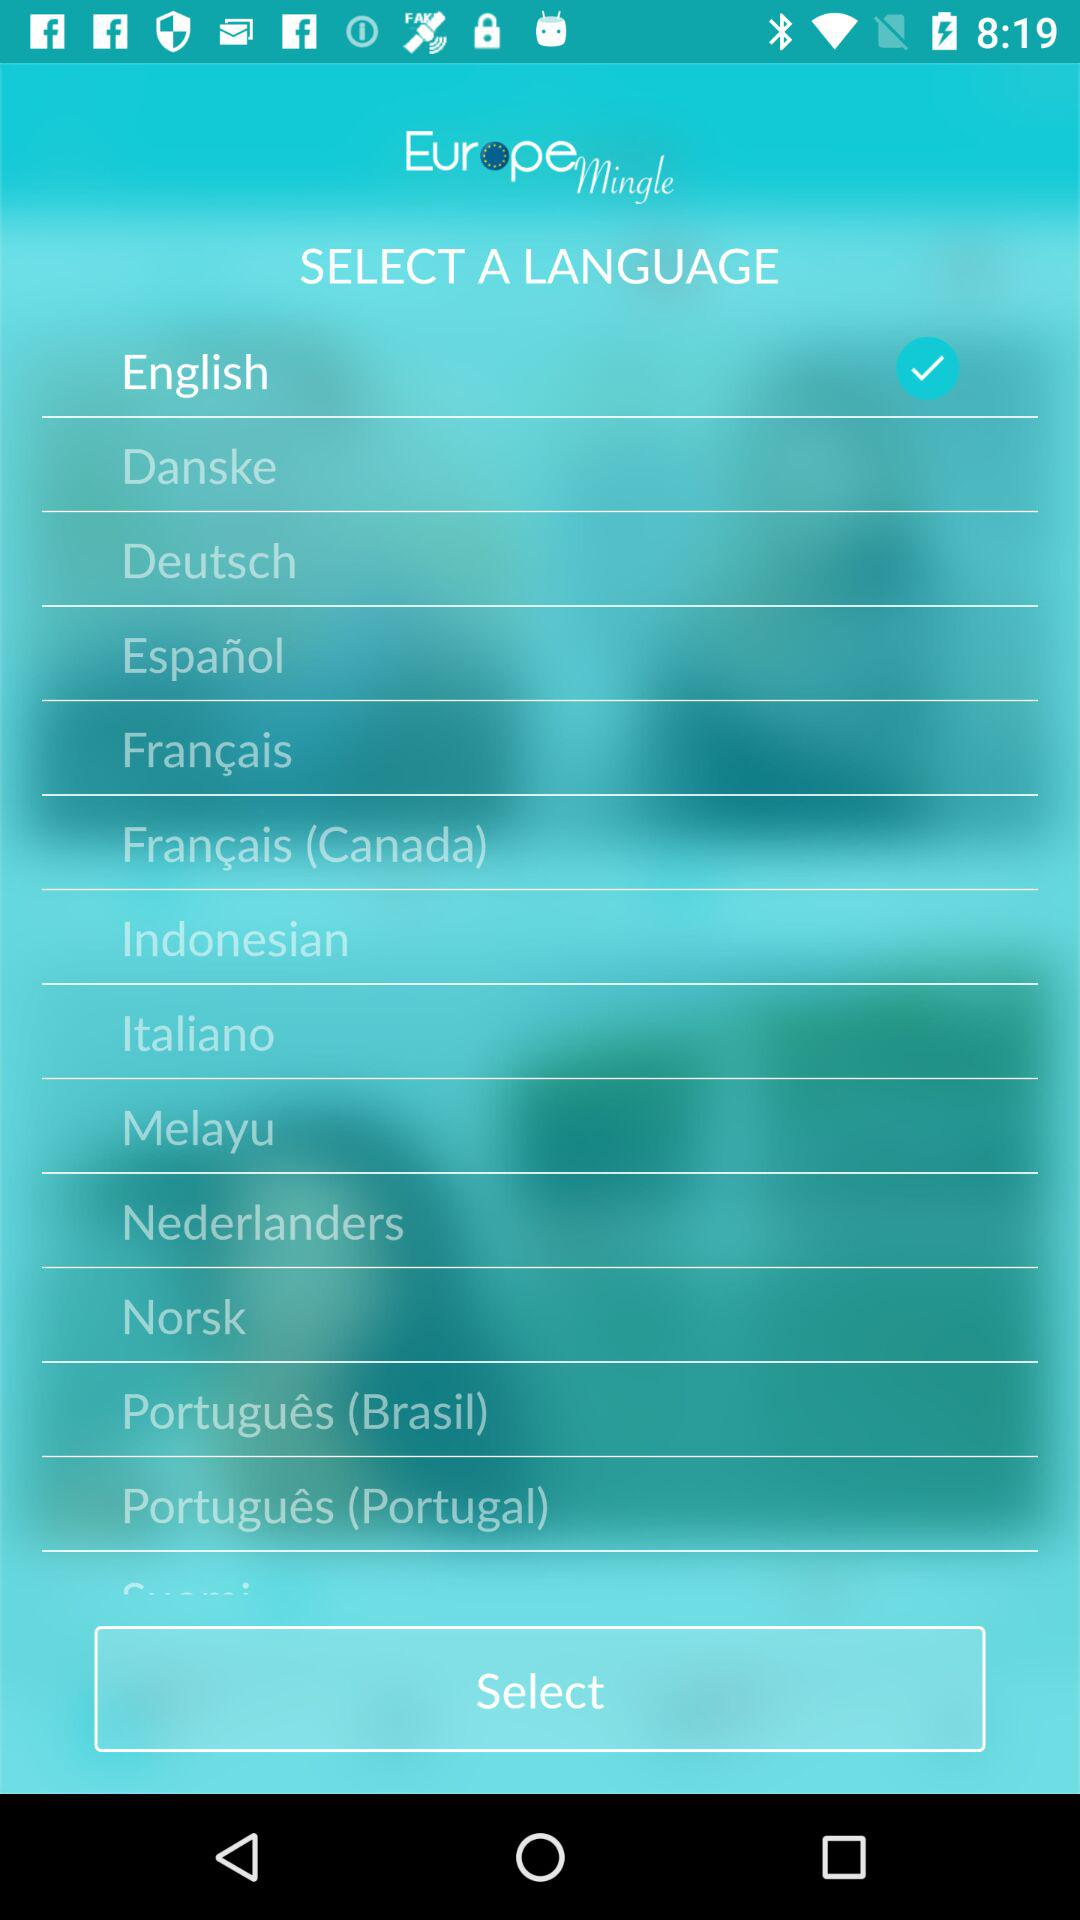What's the selected language? The selected language is "English". 